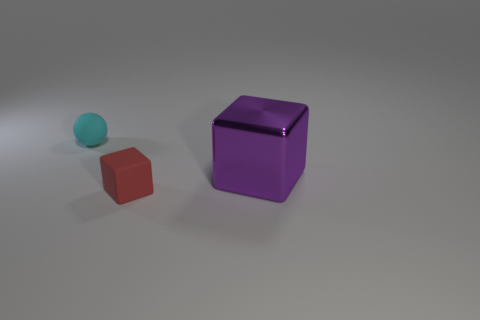Are the shapes in the foreground or the background? All three objects are placed in the foreground of the image against a neutral background, positioned in the center to draw the viewer's focus. 